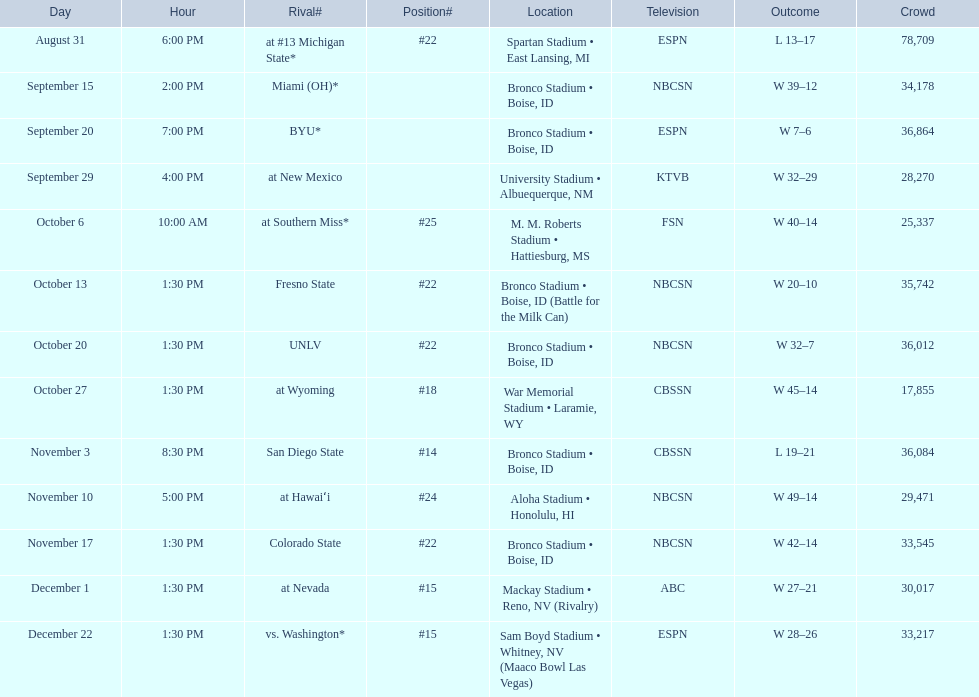Did the broncos on september 29th win by less than 5 points? Yes. 